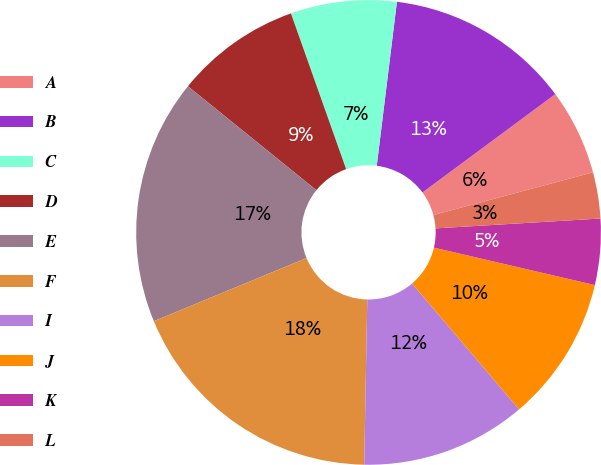Convert chart to OTSL. <chart><loc_0><loc_0><loc_500><loc_500><pie_chart><fcel>A<fcel>B<fcel>C<fcel>D<fcel>E<fcel>F<fcel>I<fcel>J<fcel>K<fcel>L<nl><fcel>5.98%<fcel>12.91%<fcel>7.37%<fcel>8.75%<fcel>17.07%<fcel>18.46%<fcel>11.52%<fcel>10.14%<fcel>4.59%<fcel>3.21%<nl></chart> 